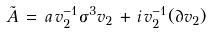Convert formula to latex. <formula><loc_0><loc_0><loc_500><loc_500>\tilde { A } \, = \, a \, v _ { 2 } ^ { - 1 } \sigma ^ { 3 } v _ { 2 } \, + \, i \, v _ { 2 } ^ { - 1 } ( \partial v _ { 2 } )</formula> 